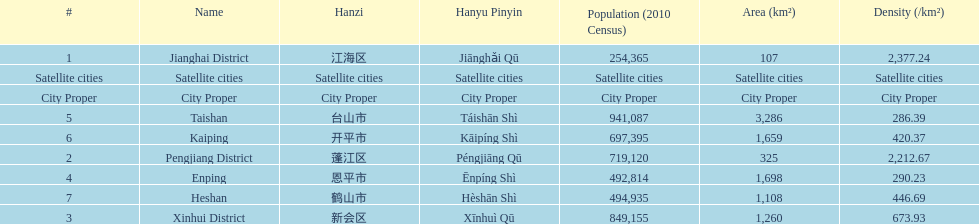Which area is the least dense? Taishan. 